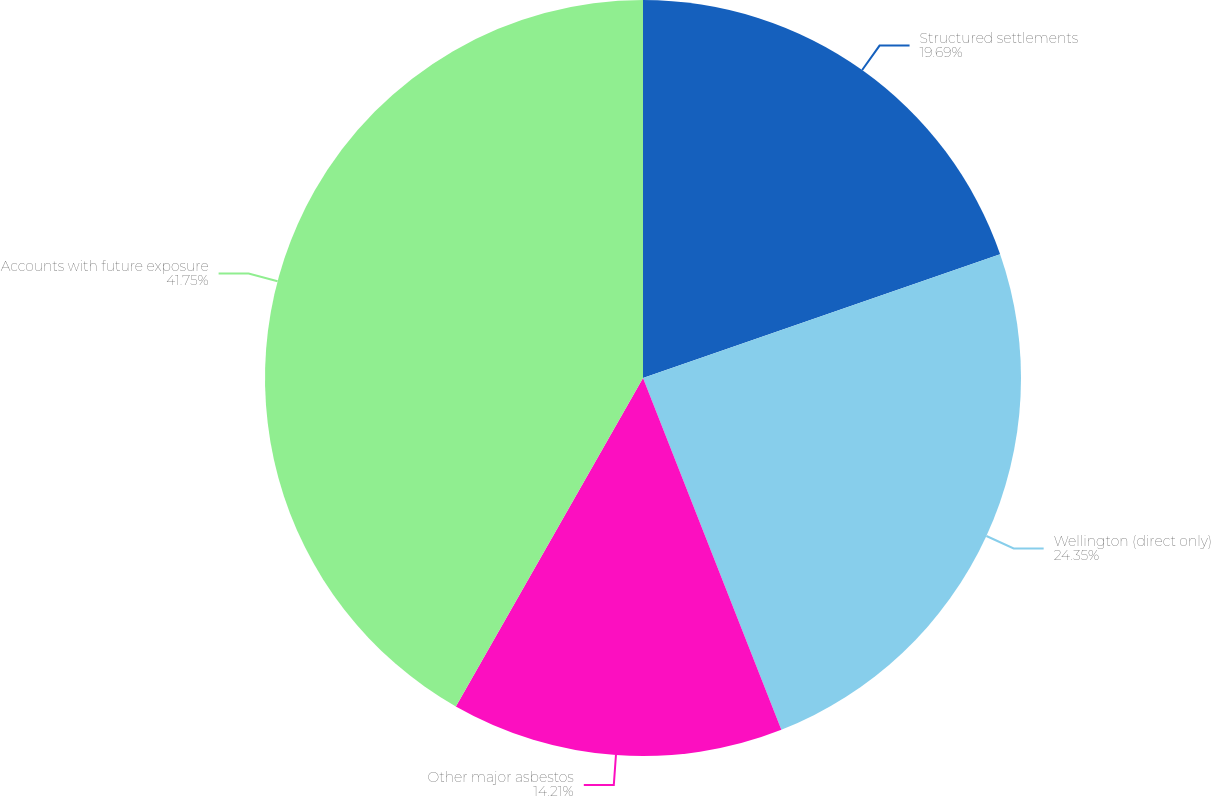Convert chart. <chart><loc_0><loc_0><loc_500><loc_500><pie_chart><fcel>Structured settlements<fcel>Wellington (direct only)<fcel>Other major asbestos<fcel>Accounts with future exposure<nl><fcel>19.69%<fcel>24.35%<fcel>14.21%<fcel>41.76%<nl></chart> 